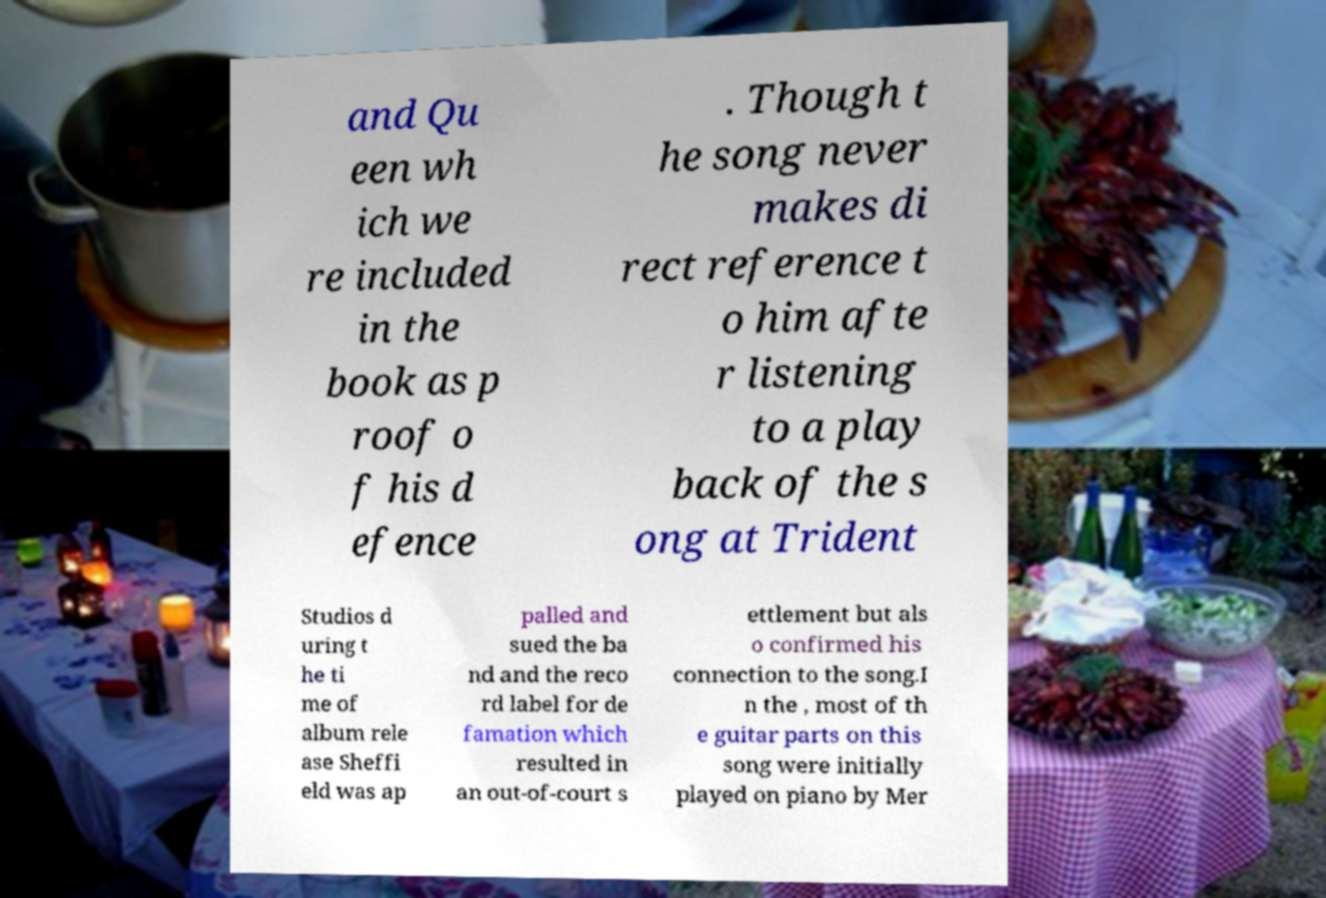Could you extract and type out the text from this image? and Qu een wh ich we re included in the book as p roof o f his d efence . Though t he song never makes di rect reference t o him afte r listening to a play back of the s ong at Trident Studios d uring t he ti me of album rele ase Sheffi eld was ap palled and sued the ba nd and the reco rd label for de famation which resulted in an out-of-court s ettlement but als o confirmed his connection to the song.I n the , most of th e guitar parts on this song were initially played on piano by Mer 